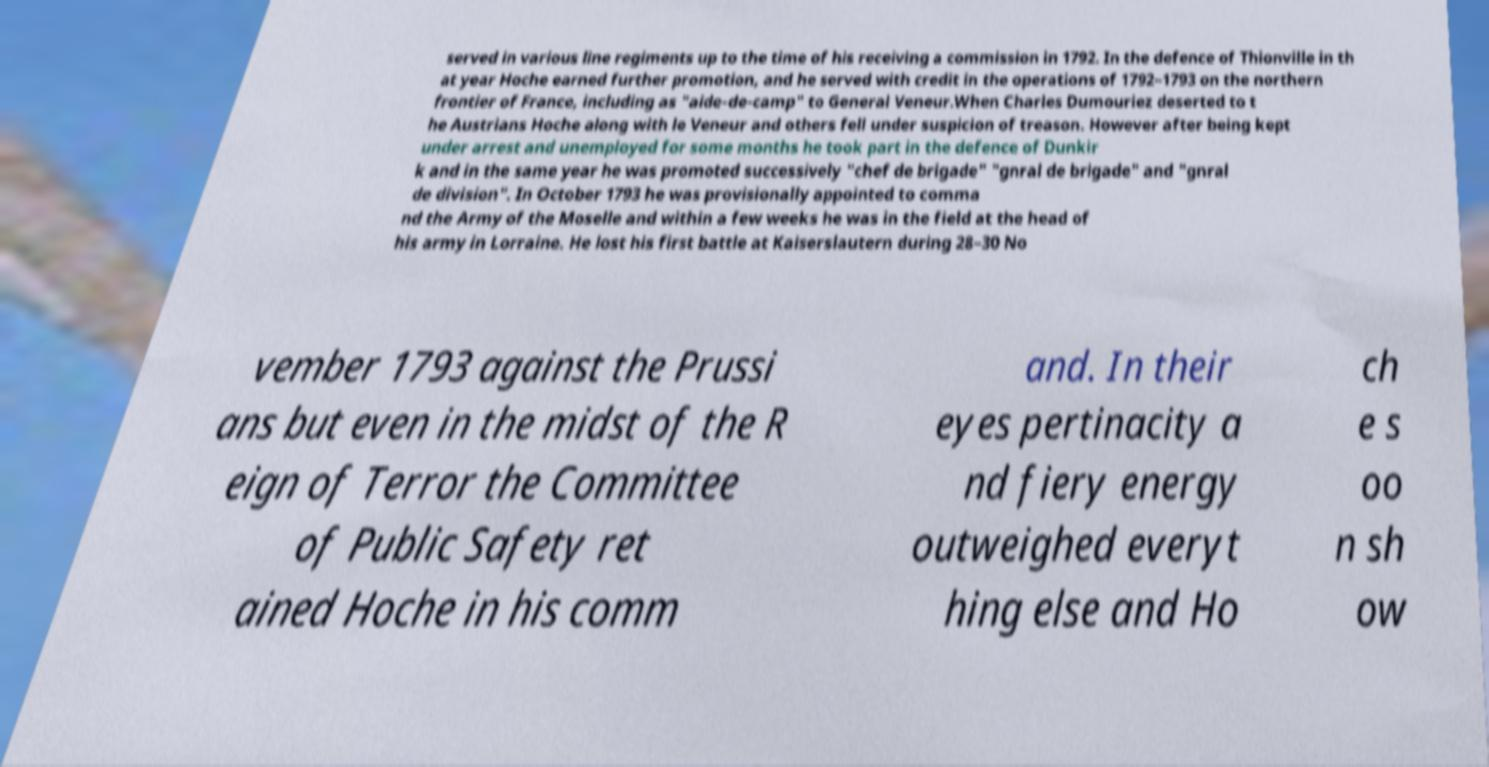I need the written content from this picture converted into text. Can you do that? served in various line regiments up to the time of his receiving a commission in 1792. In the defence of Thionville in th at year Hoche earned further promotion, and he served with credit in the operations of 1792–1793 on the northern frontier of France, including as "aide-de-camp" to General Veneur.When Charles Dumouriez deserted to t he Austrians Hoche along with le Veneur and others fell under suspicion of treason. However after being kept under arrest and unemployed for some months he took part in the defence of Dunkir k and in the same year he was promoted successively "chef de brigade" "gnral de brigade" and "gnral de division". In October 1793 he was provisionally appointed to comma nd the Army of the Moselle and within a few weeks he was in the field at the head of his army in Lorraine. He lost his first battle at Kaiserslautern during 28–30 No vember 1793 against the Prussi ans but even in the midst of the R eign of Terror the Committee of Public Safety ret ained Hoche in his comm and. In their eyes pertinacity a nd fiery energy outweighed everyt hing else and Ho ch e s oo n sh ow 